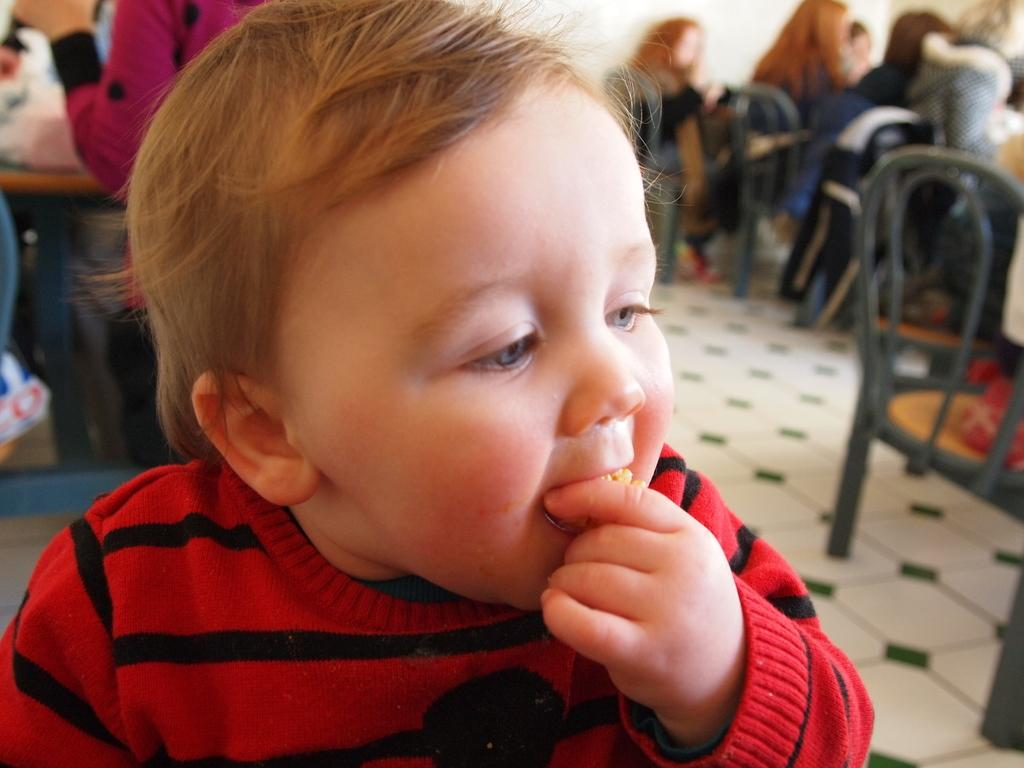What is the main subject of the image? There is a child in the image. What is the child doing in the image? The child is eating. Can you describe the setting in the background of the image? There are persons sitting on chairs in the background of the image. What type of net can be seen hanging from the ceiling in the image? There is no net present in the image; it features a child eating and persons sitting on chairs in the background. 